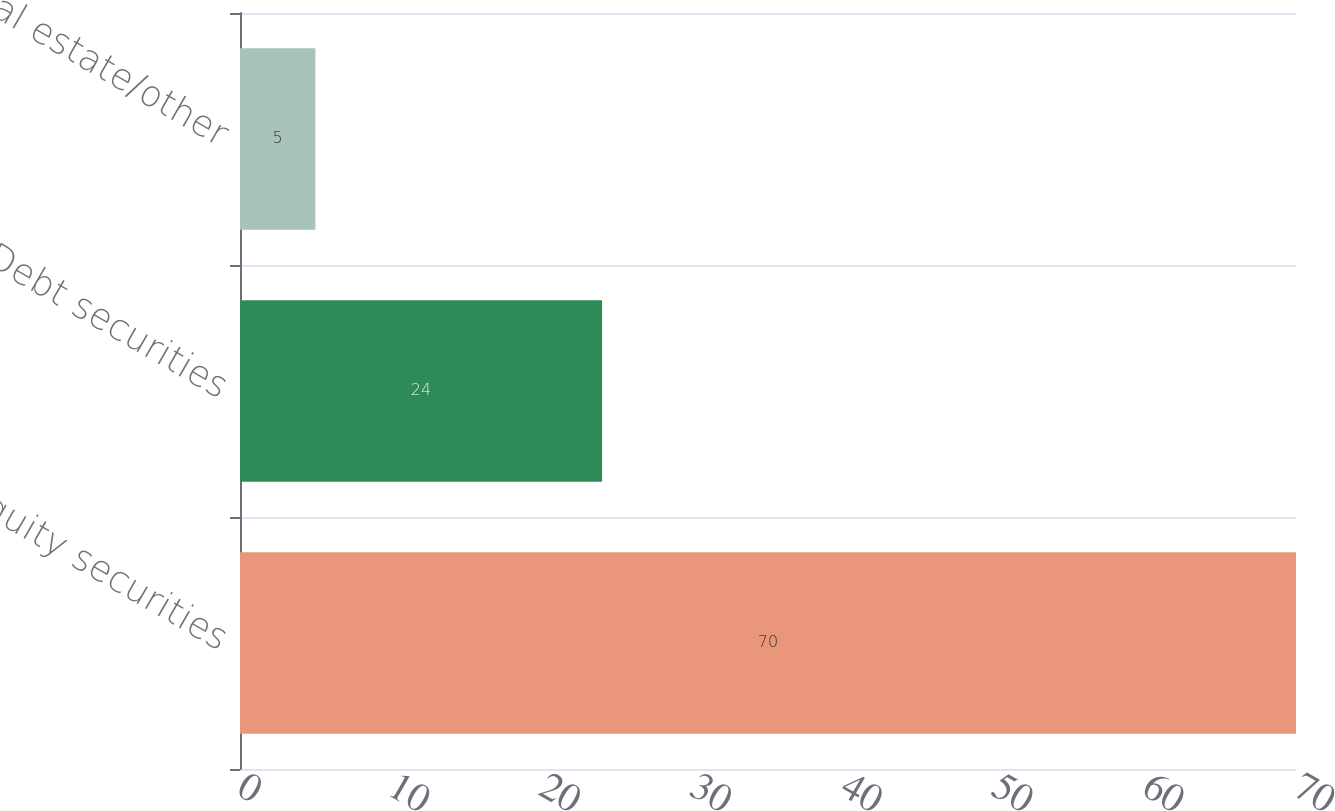Convert chart. <chart><loc_0><loc_0><loc_500><loc_500><bar_chart><fcel>Equity securities<fcel>Debt securities<fcel>Real estate/other<nl><fcel>70<fcel>24<fcel>5<nl></chart> 